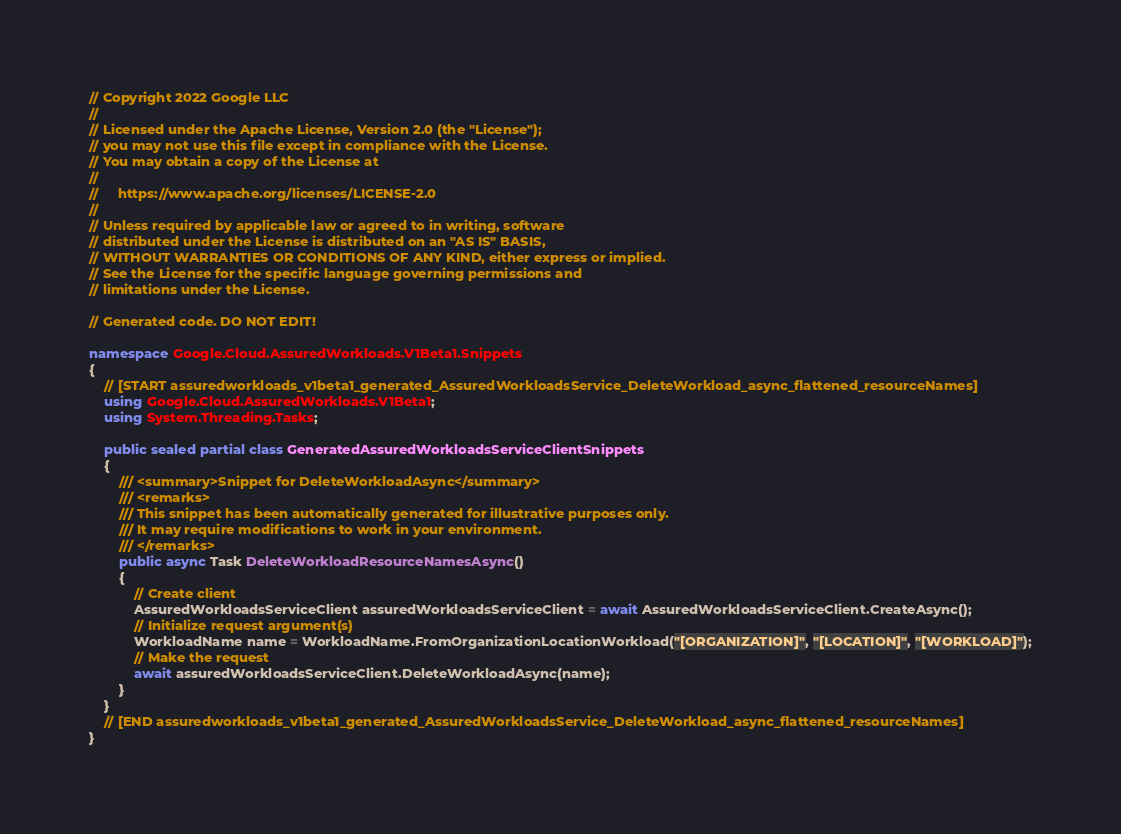Convert code to text. <code><loc_0><loc_0><loc_500><loc_500><_C#_>// Copyright 2022 Google LLC
//
// Licensed under the Apache License, Version 2.0 (the "License");
// you may not use this file except in compliance with the License.
// You may obtain a copy of the License at
//
//     https://www.apache.org/licenses/LICENSE-2.0
//
// Unless required by applicable law or agreed to in writing, software
// distributed under the License is distributed on an "AS IS" BASIS,
// WITHOUT WARRANTIES OR CONDITIONS OF ANY KIND, either express or implied.
// See the License for the specific language governing permissions and
// limitations under the License.

// Generated code. DO NOT EDIT!

namespace Google.Cloud.AssuredWorkloads.V1Beta1.Snippets
{
    // [START assuredworkloads_v1beta1_generated_AssuredWorkloadsService_DeleteWorkload_async_flattened_resourceNames]
    using Google.Cloud.AssuredWorkloads.V1Beta1;
    using System.Threading.Tasks;

    public sealed partial class GeneratedAssuredWorkloadsServiceClientSnippets
    {
        /// <summary>Snippet for DeleteWorkloadAsync</summary>
        /// <remarks>
        /// This snippet has been automatically generated for illustrative purposes only.
        /// It may require modifications to work in your environment.
        /// </remarks>
        public async Task DeleteWorkloadResourceNamesAsync()
        {
            // Create client
            AssuredWorkloadsServiceClient assuredWorkloadsServiceClient = await AssuredWorkloadsServiceClient.CreateAsync();
            // Initialize request argument(s)
            WorkloadName name = WorkloadName.FromOrganizationLocationWorkload("[ORGANIZATION]", "[LOCATION]", "[WORKLOAD]");
            // Make the request
            await assuredWorkloadsServiceClient.DeleteWorkloadAsync(name);
        }
    }
    // [END assuredworkloads_v1beta1_generated_AssuredWorkloadsService_DeleteWorkload_async_flattened_resourceNames]
}
</code> 